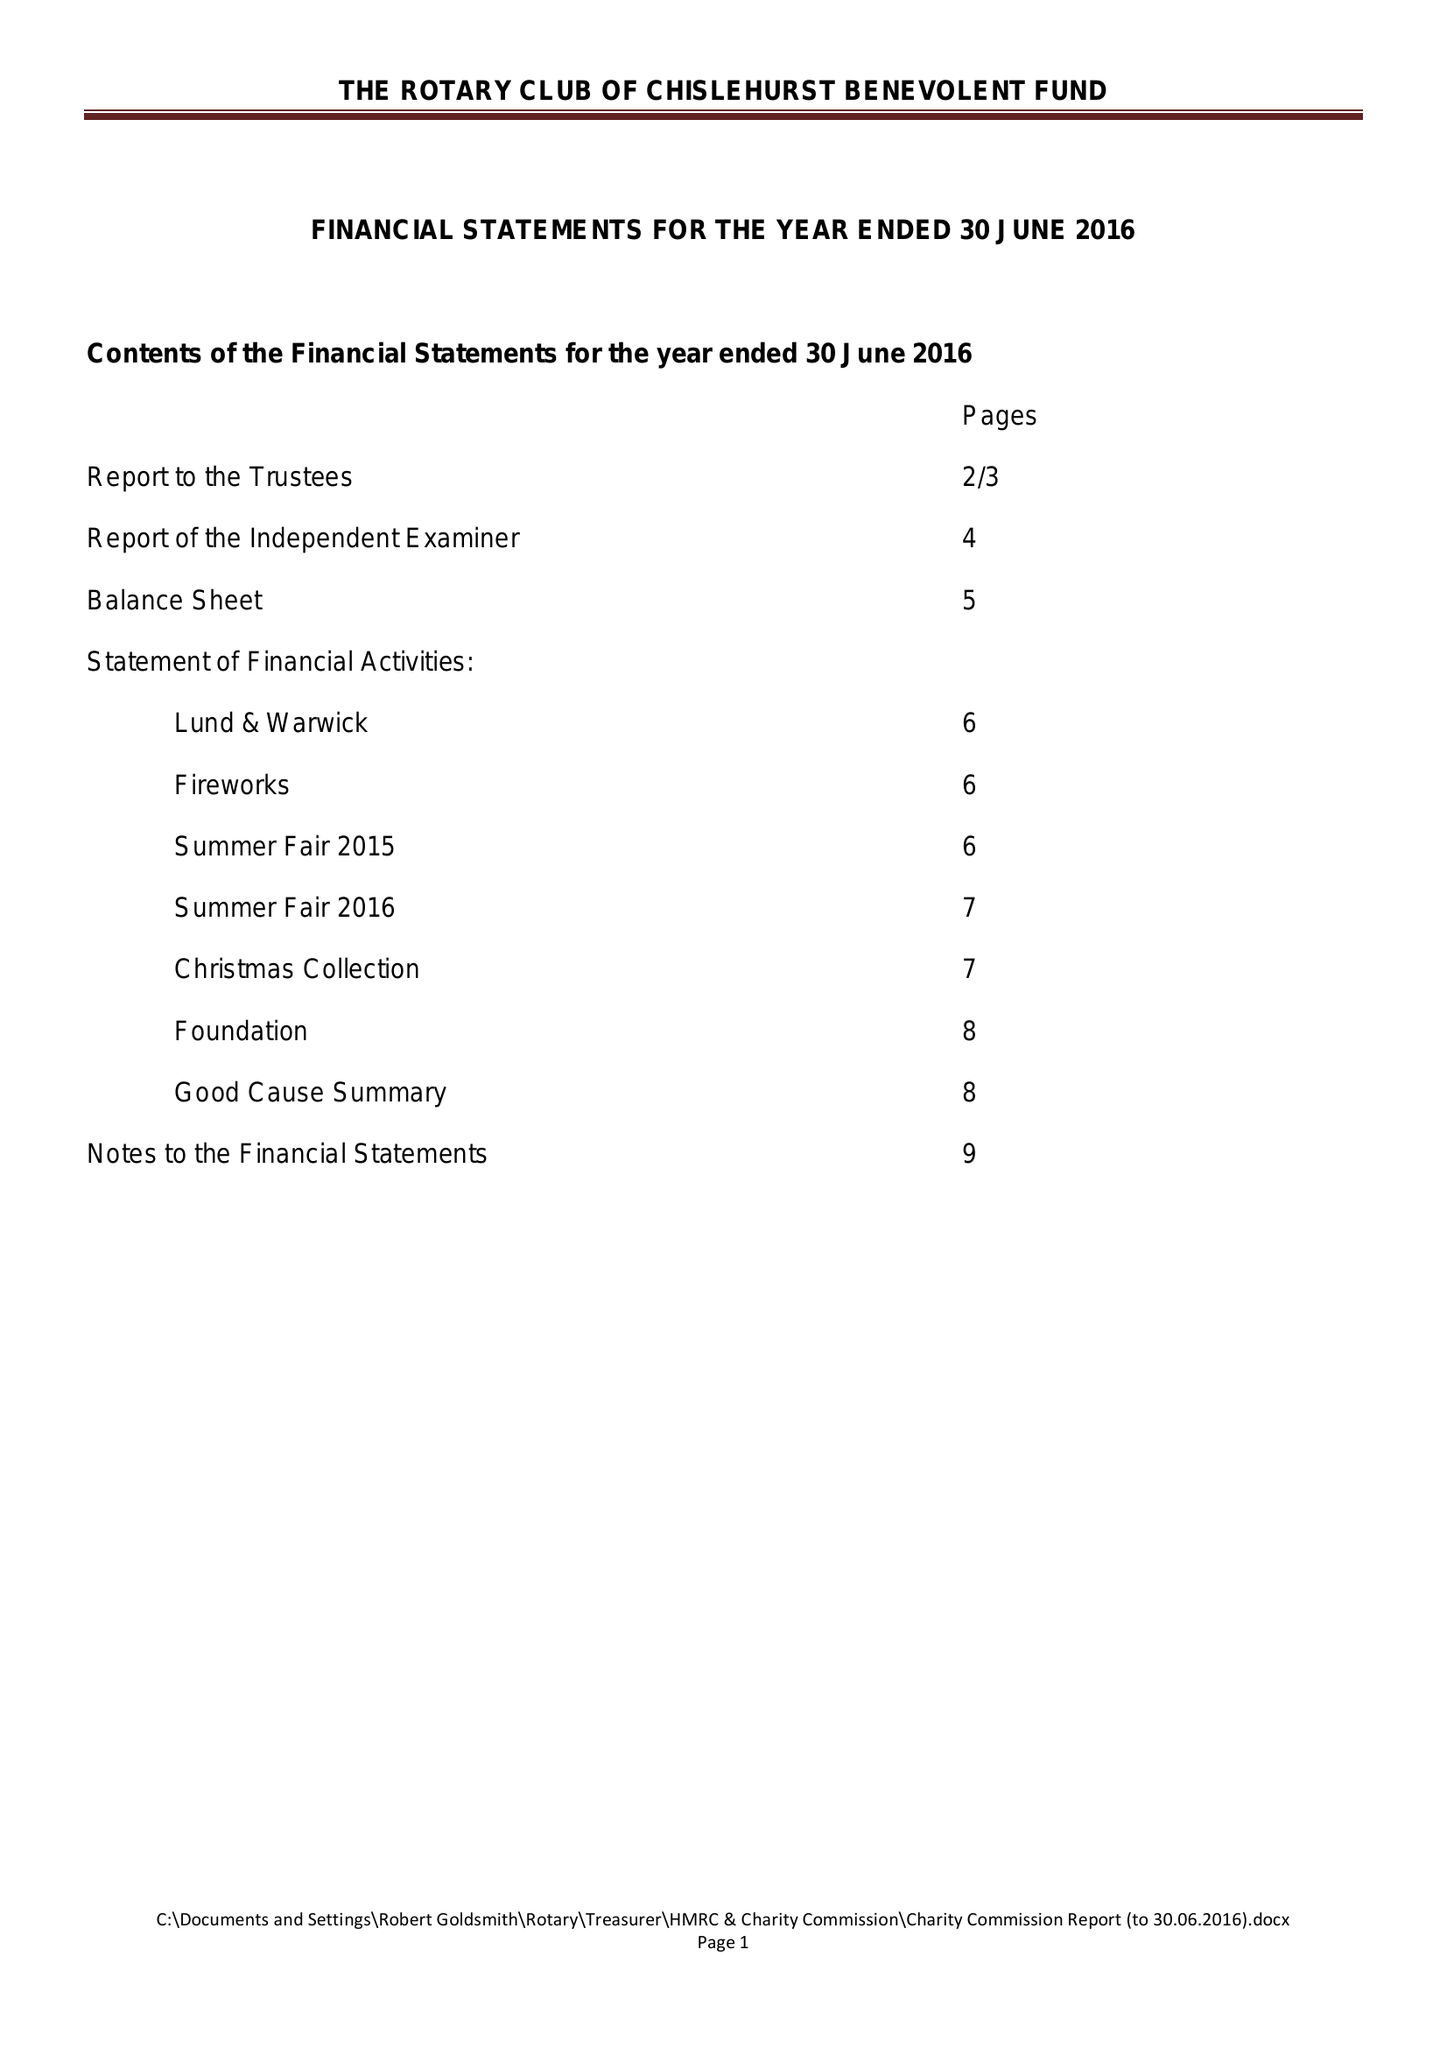What is the value for the charity_name?
Answer the question using a single word or phrase. The Rotary Club Of Chislehurst Benevolent Fund 